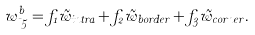<formula> <loc_0><loc_0><loc_500><loc_500>w ^ { b } _ { \mu 5 } = f _ { 1 } \tilde { w } _ { i n t r a } + f _ { 2 } \tilde { w } _ { b o r d e r } + f _ { 3 } \tilde { w } _ { c o r n e r } .</formula> 